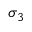<formula> <loc_0><loc_0><loc_500><loc_500>\sigma _ { 3 }</formula> 